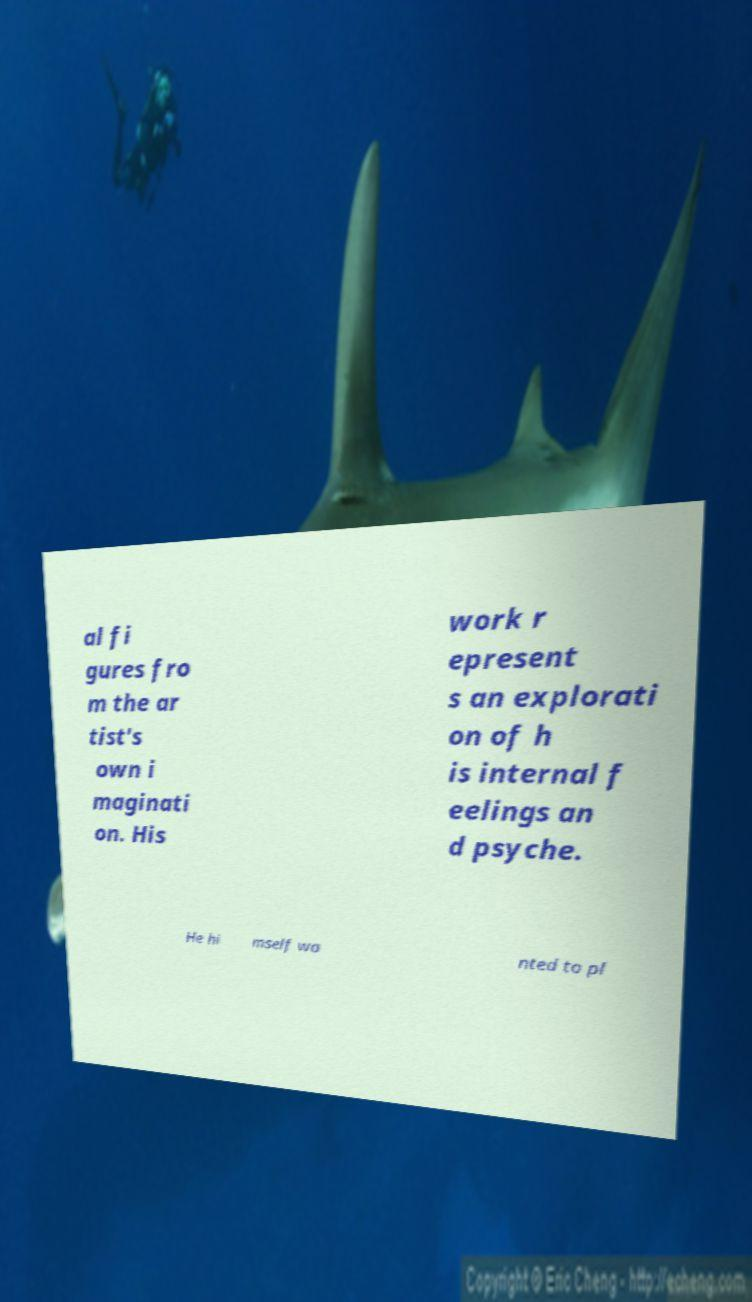Please identify and transcribe the text found in this image. al fi gures fro m the ar tist's own i maginati on. His work r epresent s an explorati on of h is internal f eelings an d psyche. He hi mself wa nted to pl 